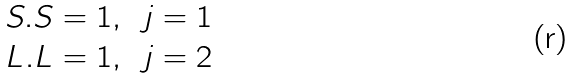Convert formula to latex. <formula><loc_0><loc_0><loc_500><loc_500>\begin{matrix} S . S = 1 , \, & j = 1 \\ L . L = 1 , \, & j = 2 \end{matrix}</formula> 